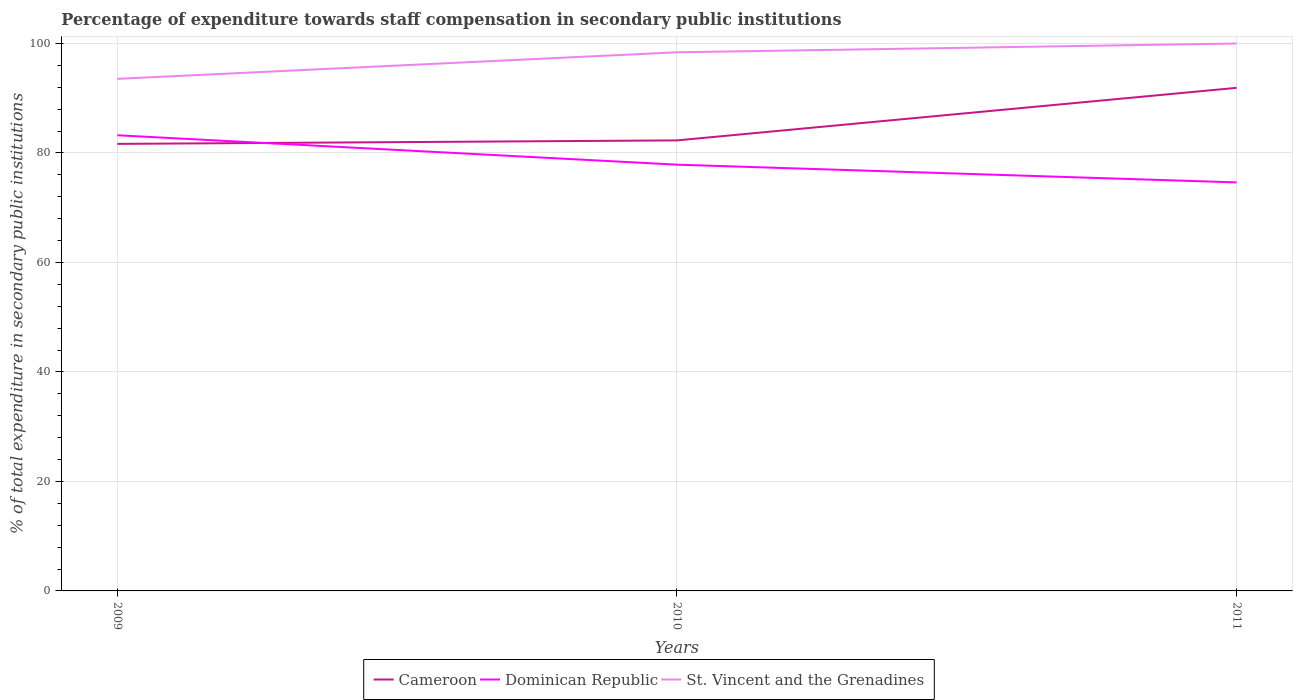Does the line corresponding to Cameroon intersect with the line corresponding to Dominican Republic?
Your answer should be compact. Yes. Across all years, what is the maximum percentage of expenditure towards staff compensation in St. Vincent and the Grenadines?
Offer a very short reply. 93.55. In which year was the percentage of expenditure towards staff compensation in Cameroon maximum?
Provide a short and direct response. 2009. What is the total percentage of expenditure towards staff compensation in Cameroon in the graph?
Ensure brevity in your answer.  -0.63. What is the difference between the highest and the second highest percentage of expenditure towards staff compensation in Cameroon?
Offer a very short reply. 10.24. What is the difference between the highest and the lowest percentage of expenditure towards staff compensation in Dominican Republic?
Provide a short and direct response. 1. How many lines are there?
Offer a very short reply. 3. How many legend labels are there?
Your response must be concise. 3. What is the title of the graph?
Ensure brevity in your answer.  Percentage of expenditure towards staff compensation in secondary public institutions. Does "Fragile and conflict affected situations" appear as one of the legend labels in the graph?
Make the answer very short. No. What is the label or title of the Y-axis?
Your response must be concise. % of total expenditure in secondary public institutions. What is the % of total expenditure in secondary public institutions of Cameroon in 2009?
Your response must be concise. 81.67. What is the % of total expenditure in secondary public institutions in Dominican Republic in 2009?
Offer a terse response. 83.24. What is the % of total expenditure in secondary public institutions in St. Vincent and the Grenadines in 2009?
Your answer should be very brief. 93.55. What is the % of total expenditure in secondary public institutions of Cameroon in 2010?
Provide a succinct answer. 82.3. What is the % of total expenditure in secondary public institutions of Dominican Republic in 2010?
Your response must be concise. 77.87. What is the % of total expenditure in secondary public institutions of St. Vincent and the Grenadines in 2010?
Offer a terse response. 98.4. What is the % of total expenditure in secondary public institutions of Cameroon in 2011?
Give a very brief answer. 91.9. What is the % of total expenditure in secondary public institutions of Dominican Republic in 2011?
Make the answer very short. 74.63. What is the % of total expenditure in secondary public institutions in St. Vincent and the Grenadines in 2011?
Provide a succinct answer. 100. Across all years, what is the maximum % of total expenditure in secondary public institutions in Cameroon?
Your answer should be compact. 91.9. Across all years, what is the maximum % of total expenditure in secondary public institutions of Dominican Republic?
Your answer should be compact. 83.24. Across all years, what is the maximum % of total expenditure in secondary public institutions in St. Vincent and the Grenadines?
Your response must be concise. 100. Across all years, what is the minimum % of total expenditure in secondary public institutions in Cameroon?
Your response must be concise. 81.67. Across all years, what is the minimum % of total expenditure in secondary public institutions of Dominican Republic?
Give a very brief answer. 74.63. Across all years, what is the minimum % of total expenditure in secondary public institutions of St. Vincent and the Grenadines?
Offer a terse response. 93.55. What is the total % of total expenditure in secondary public institutions of Cameroon in the graph?
Offer a terse response. 255.88. What is the total % of total expenditure in secondary public institutions in Dominican Republic in the graph?
Keep it short and to the point. 235.74. What is the total % of total expenditure in secondary public institutions in St. Vincent and the Grenadines in the graph?
Your answer should be compact. 291.95. What is the difference between the % of total expenditure in secondary public institutions of Cameroon in 2009 and that in 2010?
Give a very brief answer. -0.63. What is the difference between the % of total expenditure in secondary public institutions of Dominican Republic in 2009 and that in 2010?
Provide a succinct answer. 5.37. What is the difference between the % of total expenditure in secondary public institutions in St. Vincent and the Grenadines in 2009 and that in 2010?
Keep it short and to the point. -4.85. What is the difference between the % of total expenditure in secondary public institutions in Cameroon in 2009 and that in 2011?
Offer a very short reply. -10.24. What is the difference between the % of total expenditure in secondary public institutions of Dominican Republic in 2009 and that in 2011?
Your answer should be very brief. 8.61. What is the difference between the % of total expenditure in secondary public institutions in St. Vincent and the Grenadines in 2009 and that in 2011?
Provide a succinct answer. -6.45. What is the difference between the % of total expenditure in secondary public institutions in Cameroon in 2010 and that in 2011?
Your answer should be very brief. -9.6. What is the difference between the % of total expenditure in secondary public institutions in Dominican Republic in 2010 and that in 2011?
Your answer should be compact. 3.24. What is the difference between the % of total expenditure in secondary public institutions of St. Vincent and the Grenadines in 2010 and that in 2011?
Make the answer very short. -1.6. What is the difference between the % of total expenditure in secondary public institutions in Cameroon in 2009 and the % of total expenditure in secondary public institutions in Dominican Republic in 2010?
Provide a succinct answer. 3.8. What is the difference between the % of total expenditure in secondary public institutions in Cameroon in 2009 and the % of total expenditure in secondary public institutions in St. Vincent and the Grenadines in 2010?
Provide a succinct answer. -16.73. What is the difference between the % of total expenditure in secondary public institutions in Dominican Republic in 2009 and the % of total expenditure in secondary public institutions in St. Vincent and the Grenadines in 2010?
Your response must be concise. -15.16. What is the difference between the % of total expenditure in secondary public institutions of Cameroon in 2009 and the % of total expenditure in secondary public institutions of Dominican Republic in 2011?
Keep it short and to the point. 7.04. What is the difference between the % of total expenditure in secondary public institutions in Cameroon in 2009 and the % of total expenditure in secondary public institutions in St. Vincent and the Grenadines in 2011?
Offer a very short reply. -18.33. What is the difference between the % of total expenditure in secondary public institutions in Dominican Republic in 2009 and the % of total expenditure in secondary public institutions in St. Vincent and the Grenadines in 2011?
Your answer should be very brief. -16.76. What is the difference between the % of total expenditure in secondary public institutions of Cameroon in 2010 and the % of total expenditure in secondary public institutions of Dominican Republic in 2011?
Make the answer very short. 7.67. What is the difference between the % of total expenditure in secondary public institutions in Cameroon in 2010 and the % of total expenditure in secondary public institutions in St. Vincent and the Grenadines in 2011?
Give a very brief answer. -17.7. What is the difference between the % of total expenditure in secondary public institutions of Dominican Republic in 2010 and the % of total expenditure in secondary public institutions of St. Vincent and the Grenadines in 2011?
Your answer should be very brief. -22.13. What is the average % of total expenditure in secondary public institutions of Cameroon per year?
Keep it short and to the point. 85.29. What is the average % of total expenditure in secondary public institutions of Dominican Republic per year?
Offer a very short reply. 78.58. What is the average % of total expenditure in secondary public institutions of St. Vincent and the Grenadines per year?
Provide a short and direct response. 97.32. In the year 2009, what is the difference between the % of total expenditure in secondary public institutions in Cameroon and % of total expenditure in secondary public institutions in Dominican Republic?
Your answer should be compact. -1.57. In the year 2009, what is the difference between the % of total expenditure in secondary public institutions of Cameroon and % of total expenditure in secondary public institutions of St. Vincent and the Grenadines?
Give a very brief answer. -11.88. In the year 2009, what is the difference between the % of total expenditure in secondary public institutions in Dominican Republic and % of total expenditure in secondary public institutions in St. Vincent and the Grenadines?
Keep it short and to the point. -10.31. In the year 2010, what is the difference between the % of total expenditure in secondary public institutions of Cameroon and % of total expenditure in secondary public institutions of Dominican Republic?
Provide a short and direct response. 4.43. In the year 2010, what is the difference between the % of total expenditure in secondary public institutions in Cameroon and % of total expenditure in secondary public institutions in St. Vincent and the Grenadines?
Offer a very short reply. -16.09. In the year 2010, what is the difference between the % of total expenditure in secondary public institutions of Dominican Republic and % of total expenditure in secondary public institutions of St. Vincent and the Grenadines?
Your answer should be compact. -20.53. In the year 2011, what is the difference between the % of total expenditure in secondary public institutions in Cameroon and % of total expenditure in secondary public institutions in Dominican Republic?
Your answer should be compact. 17.28. In the year 2011, what is the difference between the % of total expenditure in secondary public institutions of Cameroon and % of total expenditure in secondary public institutions of St. Vincent and the Grenadines?
Your answer should be very brief. -8.1. In the year 2011, what is the difference between the % of total expenditure in secondary public institutions of Dominican Republic and % of total expenditure in secondary public institutions of St. Vincent and the Grenadines?
Keep it short and to the point. -25.37. What is the ratio of the % of total expenditure in secondary public institutions in Dominican Republic in 2009 to that in 2010?
Your response must be concise. 1.07. What is the ratio of the % of total expenditure in secondary public institutions in St. Vincent and the Grenadines in 2009 to that in 2010?
Offer a terse response. 0.95. What is the ratio of the % of total expenditure in secondary public institutions of Cameroon in 2009 to that in 2011?
Keep it short and to the point. 0.89. What is the ratio of the % of total expenditure in secondary public institutions in Dominican Republic in 2009 to that in 2011?
Ensure brevity in your answer.  1.12. What is the ratio of the % of total expenditure in secondary public institutions of St. Vincent and the Grenadines in 2009 to that in 2011?
Offer a very short reply. 0.94. What is the ratio of the % of total expenditure in secondary public institutions in Cameroon in 2010 to that in 2011?
Keep it short and to the point. 0.9. What is the ratio of the % of total expenditure in secondary public institutions of Dominican Republic in 2010 to that in 2011?
Your response must be concise. 1.04. What is the difference between the highest and the second highest % of total expenditure in secondary public institutions in Cameroon?
Provide a short and direct response. 9.6. What is the difference between the highest and the second highest % of total expenditure in secondary public institutions in Dominican Republic?
Offer a terse response. 5.37. What is the difference between the highest and the second highest % of total expenditure in secondary public institutions in St. Vincent and the Grenadines?
Your answer should be compact. 1.6. What is the difference between the highest and the lowest % of total expenditure in secondary public institutions of Cameroon?
Your response must be concise. 10.24. What is the difference between the highest and the lowest % of total expenditure in secondary public institutions in Dominican Republic?
Provide a short and direct response. 8.61. What is the difference between the highest and the lowest % of total expenditure in secondary public institutions in St. Vincent and the Grenadines?
Ensure brevity in your answer.  6.45. 